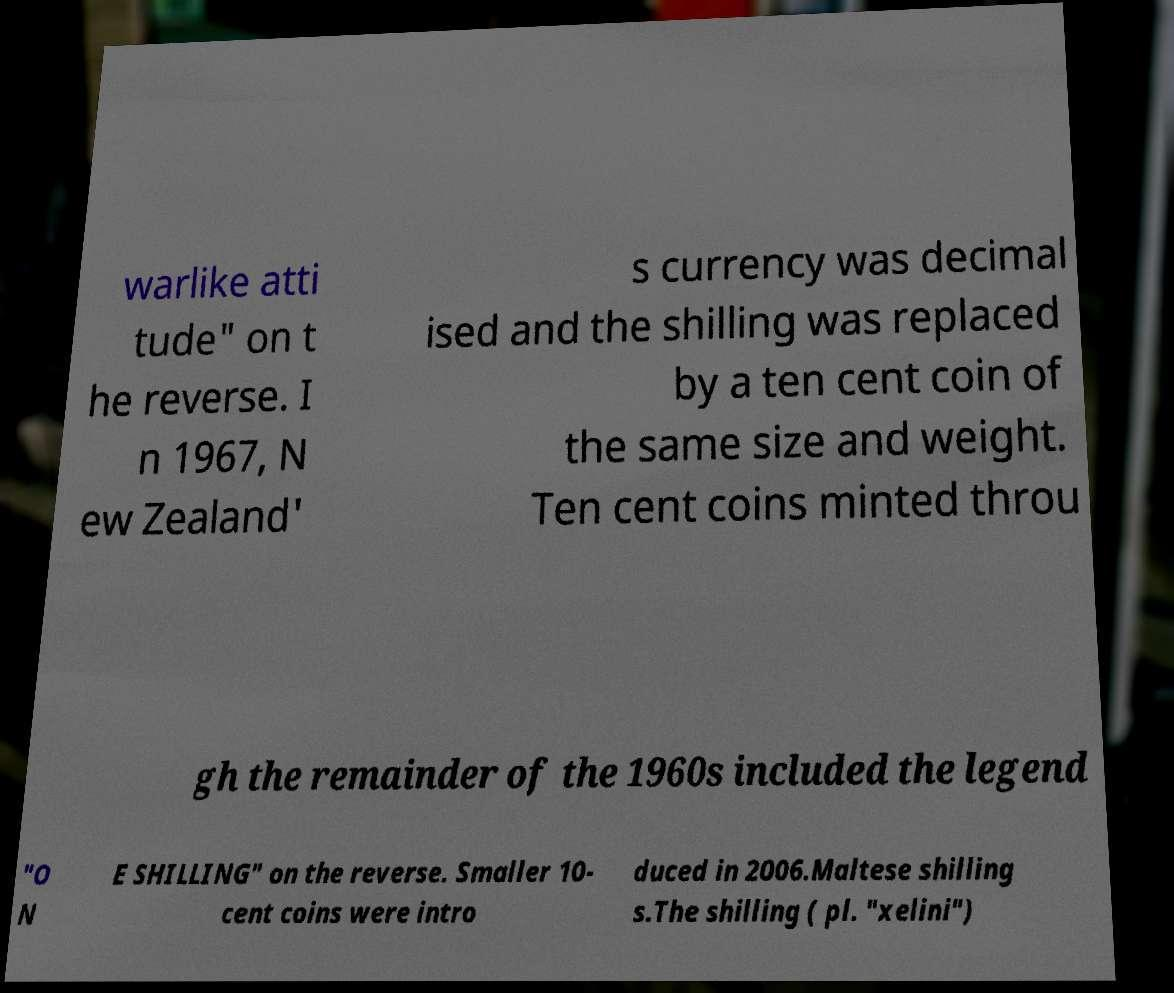There's text embedded in this image that I need extracted. Can you transcribe it verbatim? warlike atti tude" on t he reverse. I n 1967, N ew Zealand' s currency was decimal ised and the shilling was replaced by a ten cent coin of the same size and weight. Ten cent coins minted throu gh the remainder of the 1960s included the legend "O N E SHILLING" on the reverse. Smaller 10- cent coins were intro duced in 2006.Maltese shilling s.The shilling ( pl. "xelini") 